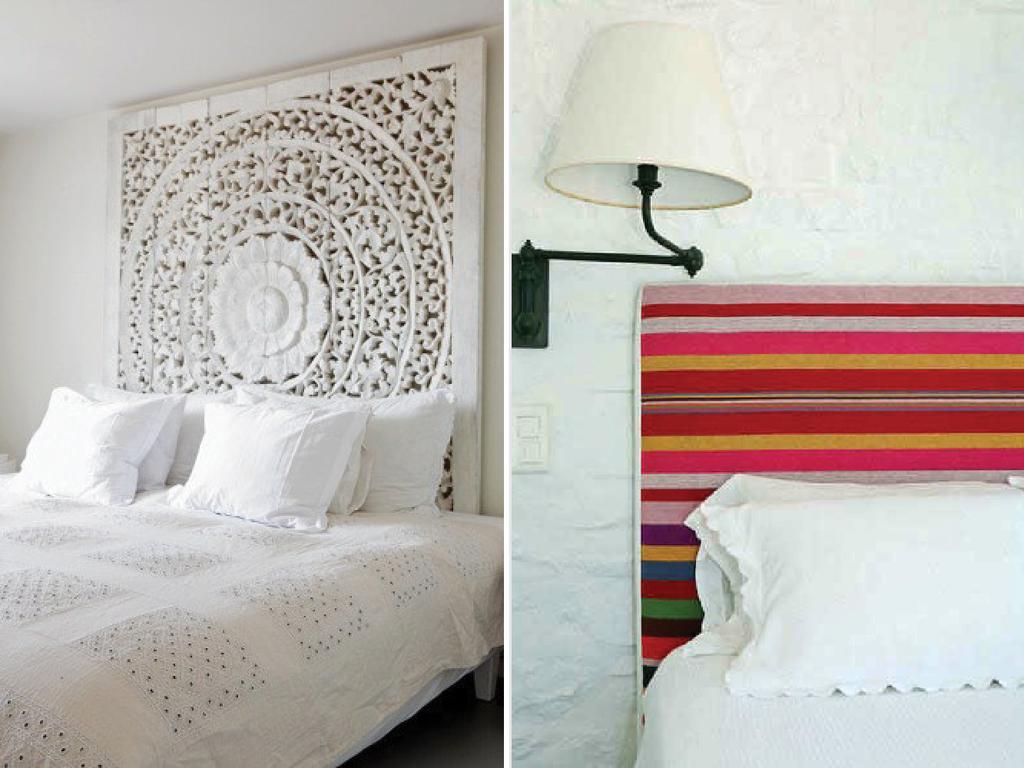Please provide a concise description of this image. This is the image of a bedroom where is there is a white color frame attached to the wall and there is a bed with white color blanket and at the left side there are 3 white pillows and at the right side there are other 3 pillows and at the wall there is white color lamp attached to it and there is a bed with multi color frame and there is a white blanket with the 2 pillows on it. 